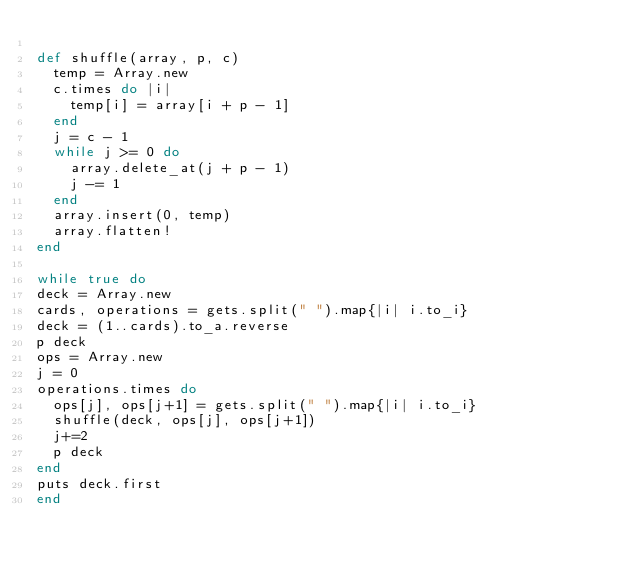Convert code to text. <code><loc_0><loc_0><loc_500><loc_500><_Ruby_>
def shuffle(array, p, c)
  temp = Array.new
  c.times do |i|
    temp[i] = array[i + p - 1]
  end
  j = c - 1
  while j >= 0 do
    array.delete_at(j + p - 1)
    j -= 1
  end
  array.insert(0, temp)
  array.flatten!
end

while true do
deck = Array.new
cards, operations = gets.split(" ").map{|i| i.to_i}
deck = (1..cards).to_a.reverse
p deck
ops = Array.new
j = 0
operations.times do
  ops[j], ops[j+1] = gets.split(" ").map{|i| i.to_i}
  shuffle(deck, ops[j], ops[j+1])
  j+=2
  p deck
end
puts deck.first
end</code> 